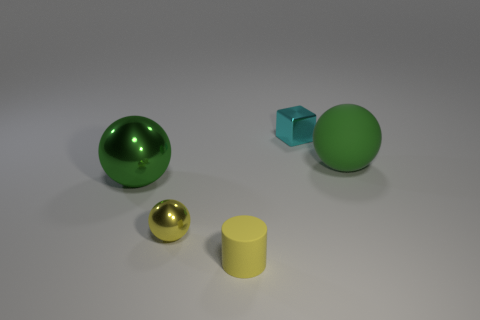Are there any other things that have the same material as the cyan object?
Make the answer very short. Yes. Are the small cyan object and the yellow cylinder made of the same material?
Your answer should be compact. No. Is there a small yellow thing that has the same shape as the small cyan object?
Offer a terse response. No. Do the big object on the left side of the tiny metallic block and the cylinder have the same color?
Make the answer very short. No. There is a yellow object in front of the yellow shiny sphere; is its size the same as the metal object to the right of the small yellow shiny ball?
Offer a terse response. Yes. There is a thing that is made of the same material as the tiny cylinder; what is its size?
Ensure brevity in your answer.  Large. What number of things are both behind the green rubber object and in front of the yellow metallic sphere?
Offer a very short reply. 0. How many objects are cyan shiny things or small metallic things that are in front of the cyan shiny thing?
Give a very brief answer. 2. There is another thing that is the same color as the small rubber object; what is its shape?
Offer a terse response. Sphere. What is the color of the shiny object behind the green shiny thing?
Offer a terse response. Cyan. 